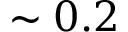<formula> <loc_0><loc_0><loc_500><loc_500>\sim 0 . 2</formula> 